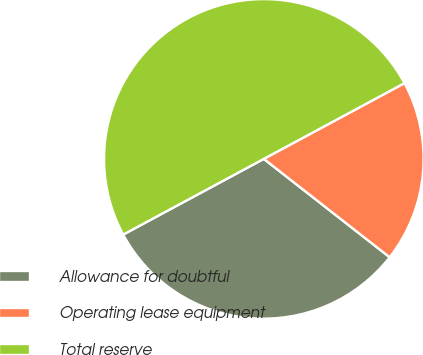Convert chart. <chart><loc_0><loc_0><loc_500><loc_500><pie_chart><fcel>Allowance for doubtful<fcel>Operating lease equipment<fcel>Total reserve<nl><fcel>31.58%<fcel>18.42%<fcel>50.0%<nl></chart> 